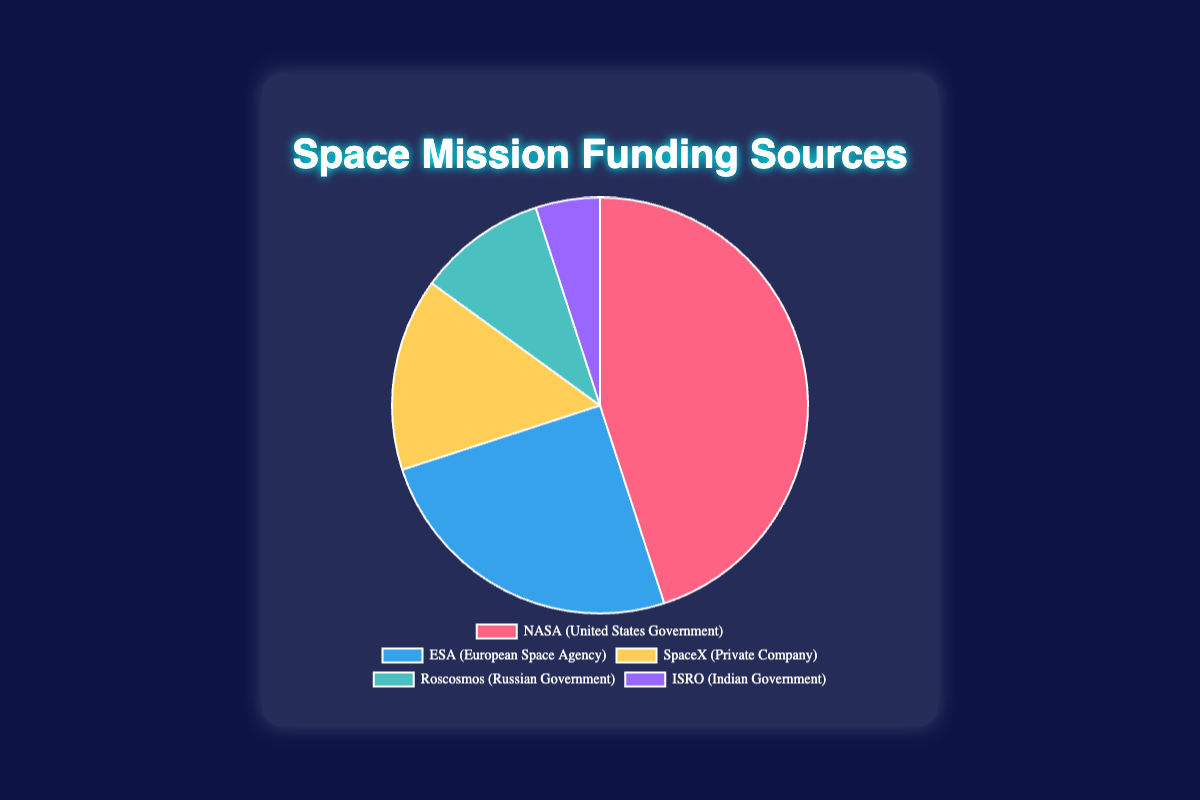What percentage of funding is provided by private companies compared to governments? The private company (SpaceX) provides 15% of the funding. Government sources (NASA, Roscosmos, ISRO) together provide a total of 45% + 10% + 5% = 60%. Comparing these, private companies provide 15%, while governments provide 60%.
Answer: 15% vs 60% Which entity contributes more to the funding: ESA or ISRO? ESA contributes 25% of the funding, while ISRO contributes 5%. Therefore, the ESA contributes more.
Answer: ESA What is the combined funding percentage from NASA and SpaceX? NASA contributes 45% and SpaceX contributes 15%. Their combined contribution is 45% + 15% = 60%.
Answer: 60% Are the funding contributions from Roscosmos and ISRO together greater than the contribution from SpaceX? Roscosmos contributes 10% and ISRO contributes 5%, so together they contribute 10% + 5% = 15%. This matches the contribution of SpaceX, which is also 15%.
Answer: No, they are equal Out of all the sources, which one provides the least funding? By looking at the percentages, ISRO provides the least funding at 5%.
Answer: ISRO How much more funding does NASA provide compared to ESA? NASA provides 45% and ESA provides 25%. The difference in their contributions is 45% - 25% = 20%.
Answer: 20% What is the average funding percentage from Roscosmos and ISRO? Roscosmos provides 10% and ISRO provides 5%. Their average funding percentage is (10% + 5%) / 2 = 15% / 2 = 7.5%.
Answer: 7.5% What is the visual color representation for ESA and SpaceX in the chart? ESA is represented by blue and SpaceX by yellow in the pie chart.
Answer: Blue for ESA, Yellow for SpaceX How much more funding in percentage points does NASA provide compared to the combined contributions of Roscosmos and ISRO? NASA provides 45%. The combined contributions of Roscosmos and ISRO are 10% + 5% = 15%. The difference is 45% - 15% = 30%.
Answer: 30% What is the predominant color in the chart, representing the largest funding source? The largest funding source is NASA at 45%, which is represented by red in the pie chart.
Answer: Red 